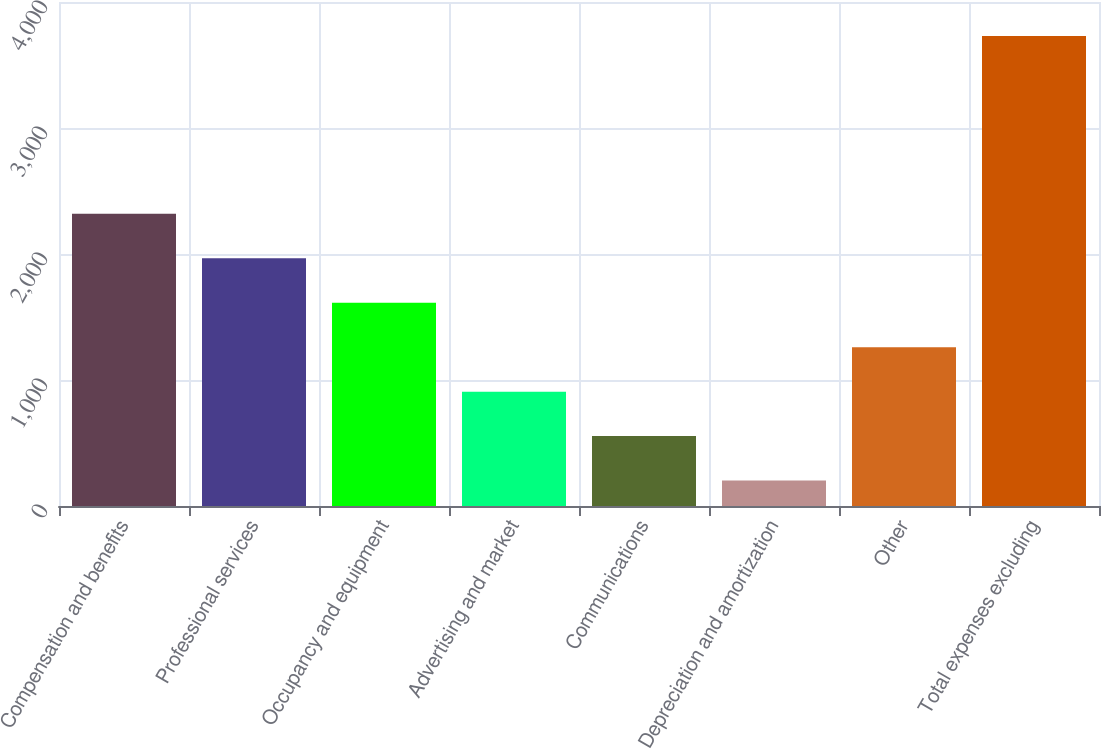Convert chart. <chart><loc_0><loc_0><loc_500><loc_500><bar_chart><fcel>Compensation and benefits<fcel>Professional services<fcel>Occupancy and equipment<fcel>Advertising and market<fcel>Communications<fcel>Depreciation and amortization<fcel>Other<fcel>Total expenses excluding<nl><fcel>2318.8<fcel>1966<fcel>1613.2<fcel>907.6<fcel>554.8<fcel>202<fcel>1260.4<fcel>3730<nl></chart> 